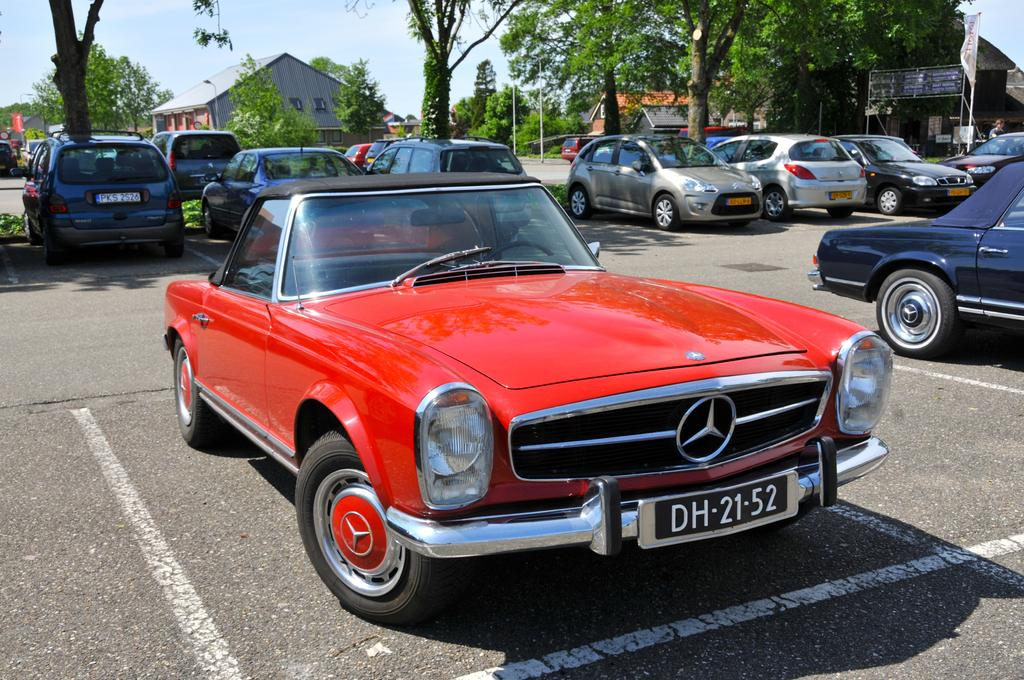What is there are what types of objects in the image? There are vehicles in the image. Where are the vehicles located? The vehicles are in one place. What other types of structures can be seen in the image? There are houses in the image. What type of natural elements are present in the image? Trees are present in the image. What type of face can be seen on the trees in the image? There are no faces present on the trees in the image. What type of clouds can be seen in the image? There is no mention of clouds in the provided facts, so we cannot determine if clouds are present in the image. 